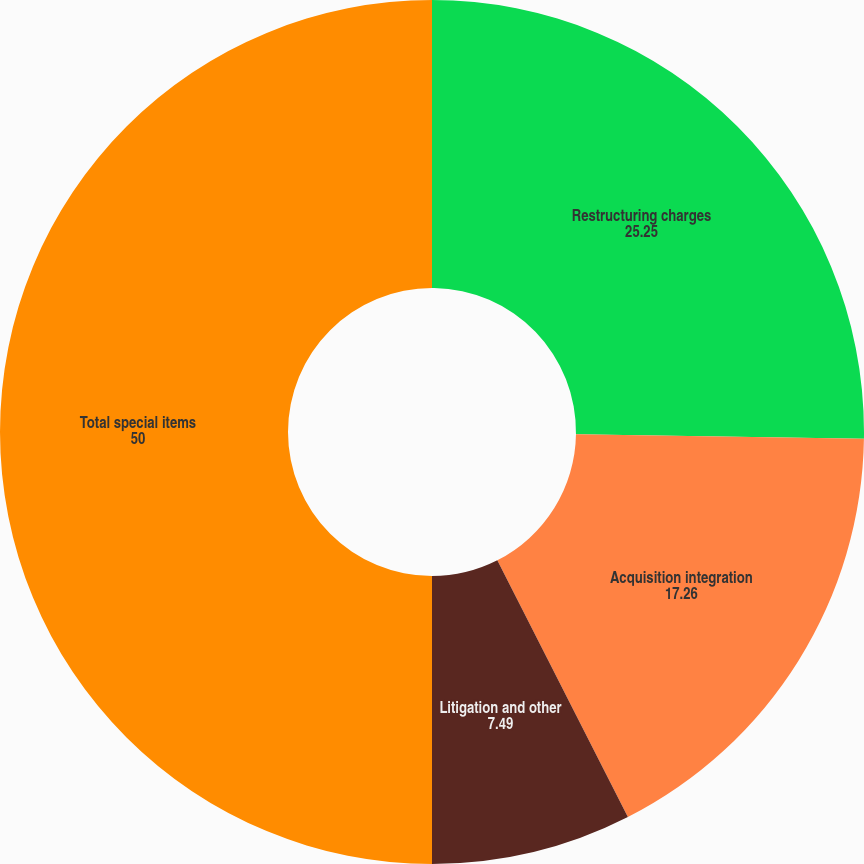Convert chart to OTSL. <chart><loc_0><loc_0><loc_500><loc_500><pie_chart><fcel>Restructuring charges<fcel>Acquisition integration<fcel>Litigation and other<fcel>Total special items<nl><fcel>25.25%<fcel>17.26%<fcel>7.49%<fcel>50.0%<nl></chart> 